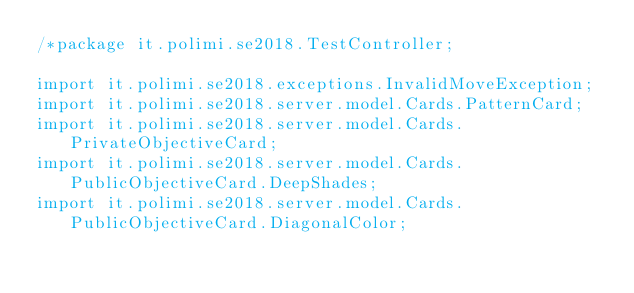Convert code to text. <code><loc_0><loc_0><loc_500><loc_500><_Java_>/*package it.polimi.se2018.TestController;

import it.polimi.se2018.exceptions.InvalidMoveException;
import it.polimi.se2018.server.model.Cards.PatternCard;
import it.polimi.se2018.server.model.Cards.PrivateObjectiveCard;
import it.polimi.se2018.server.model.Cards.PublicObjectiveCard.DeepShades;
import it.polimi.se2018.server.model.Cards.PublicObjectiveCard.DiagonalColor;</code> 